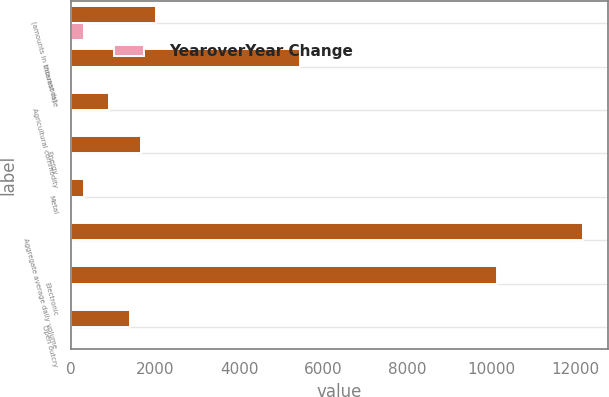Convert chart to OTSL. <chart><loc_0><loc_0><loc_500><loc_500><stacked_bar_chart><ecel><fcel>(amounts in thousands)<fcel>Interest rate<fcel>Agricultural commodity<fcel>Energy<fcel>Metal<fcel>Aggregate average daily volume<fcel>Electronic<fcel>Open outcry<nl><fcel>nan<fcel>2010<fcel>5449<fcel>914<fcel>1662<fcel>316<fcel>12167<fcel>10120<fcel>1402<nl><fcel>YearoverYear Change<fcel>316<fcel>28<fcel>23<fcel>11<fcel>40<fcel>19<fcel>22<fcel>7<nl></chart> 